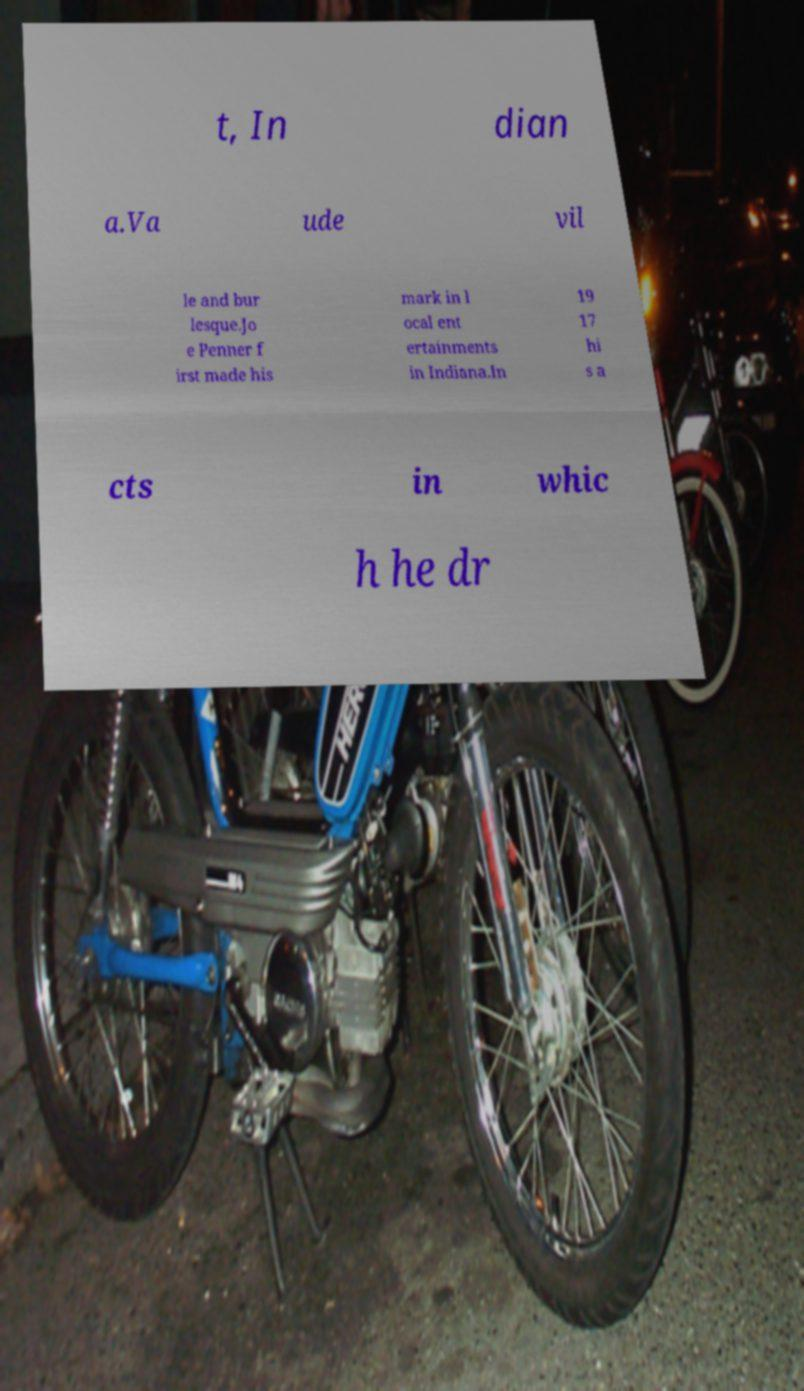Can you accurately transcribe the text from the provided image for me? t, In dian a.Va ude vil le and bur lesque.Jo e Penner f irst made his mark in l ocal ent ertainments in Indiana.In 19 17 hi s a cts in whic h he dr 